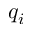Convert formula to latex. <formula><loc_0><loc_0><loc_500><loc_500>q _ { i }</formula> 